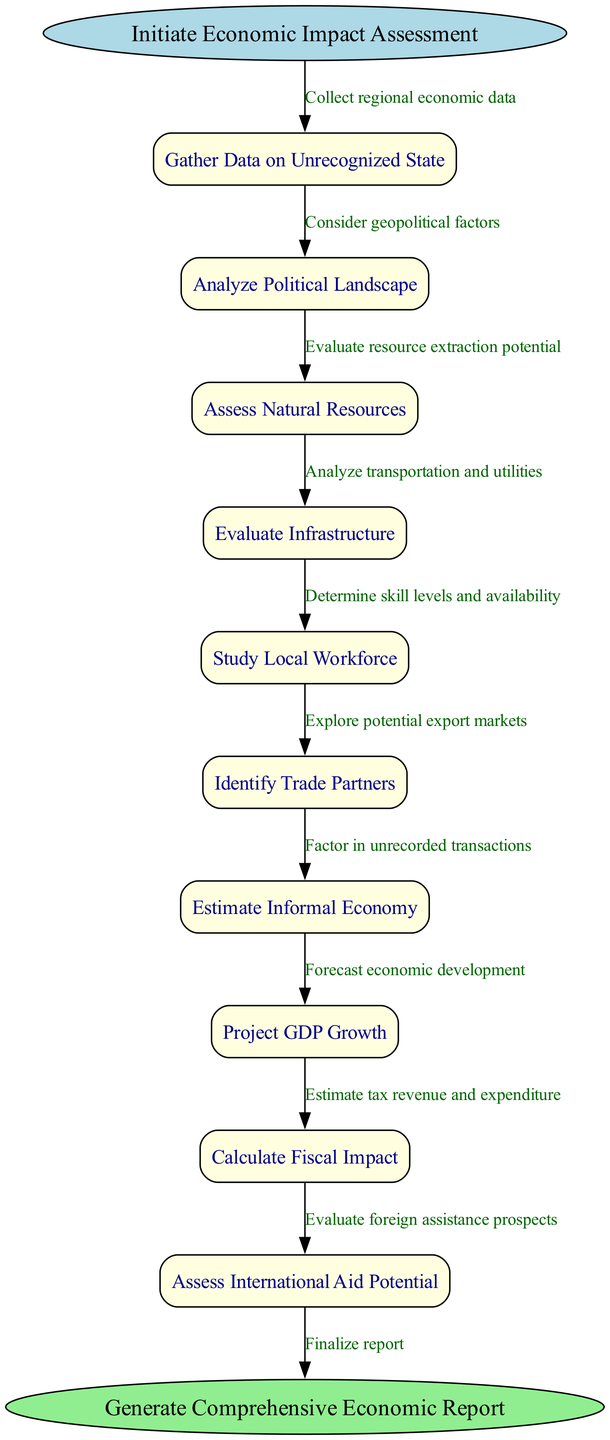What is the starting point of the economic impact assessment process? The diagram shows "Initiate Economic Impact Assessment" as the starting point, which is labeled clearly in the start node.
Answer: Initiate Economic Impact Assessment How many intermediate nodes are there in the process? The diagram includes ten nodes, nine of which are intermediate steps that contribute to the assessment process between the start and end nodes.
Answer: 10 What edge describes the data gathering phase? The edge labeled "Collect regional economic data" connects the starting point to the first node, indicating that this is the primary activity in the initial phase.
Answer: Collect regional economic data Which node evaluates resource extraction potential? The node "Assess Natural Resources" is specifically designated to evaluate resource extraction potential, as reflected in its title.
Answer: Assess Natural Resources What is the last node before generating the report? The last intermediate node in the assessment process is "Assess International Aid Potential," which leads to the end node where the report is finalized.
Answer: Assess International Aid Potential How many edges lead into the final report generation? There is one edge leading directly into the final node "Generate Comprehensive Economic Report," illustrating the completion of the assessment process.
Answer: 1 What connection explains the analysis of the transportation and utilities? The connection labeled "Analyze transportation and utilities" comes from the node "Evaluate Infrastructure," detailing what is evaluated in that stage.
Answer: Analyze transportation and utilities Which aspect of the local economy is not officially recorded as per the diagram? The edge labeled "Factor in unrecorded transactions" indicates that the informal economy is addressed but not officially recognized in the economic assessments.
Answer: Informal Economy What does the node "Project GDP Growth" focus on? This node specifically refers to estimating future economic development and growth in the context of the unrecognized state's economy.
Answer: Forecast economic development 